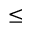Convert formula to latex. <formula><loc_0><loc_0><loc_500><loc_500>\leq</formula> 